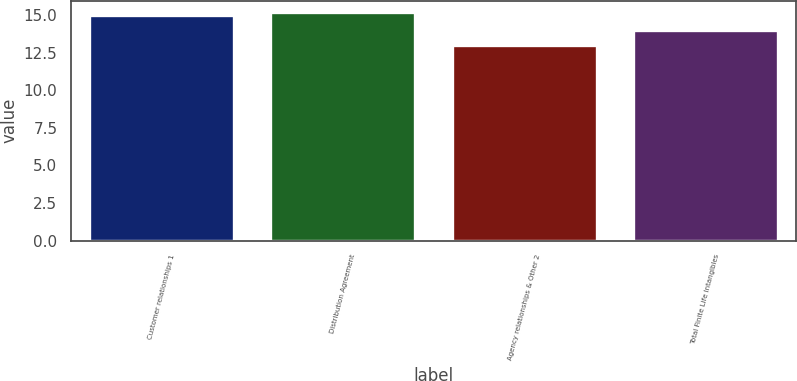<chart> <loc_0><loc_0><loc_500><loc_500><bar_chart><fcel>Customer relationships 1<fcel>Distribution Agreement<fcel>Agency relationships & Other 2<fcel>Total Finite Life Intangibles<nl><fcel>15<fcel>15.2<fcel>13<fcel>14<nl></chart> 